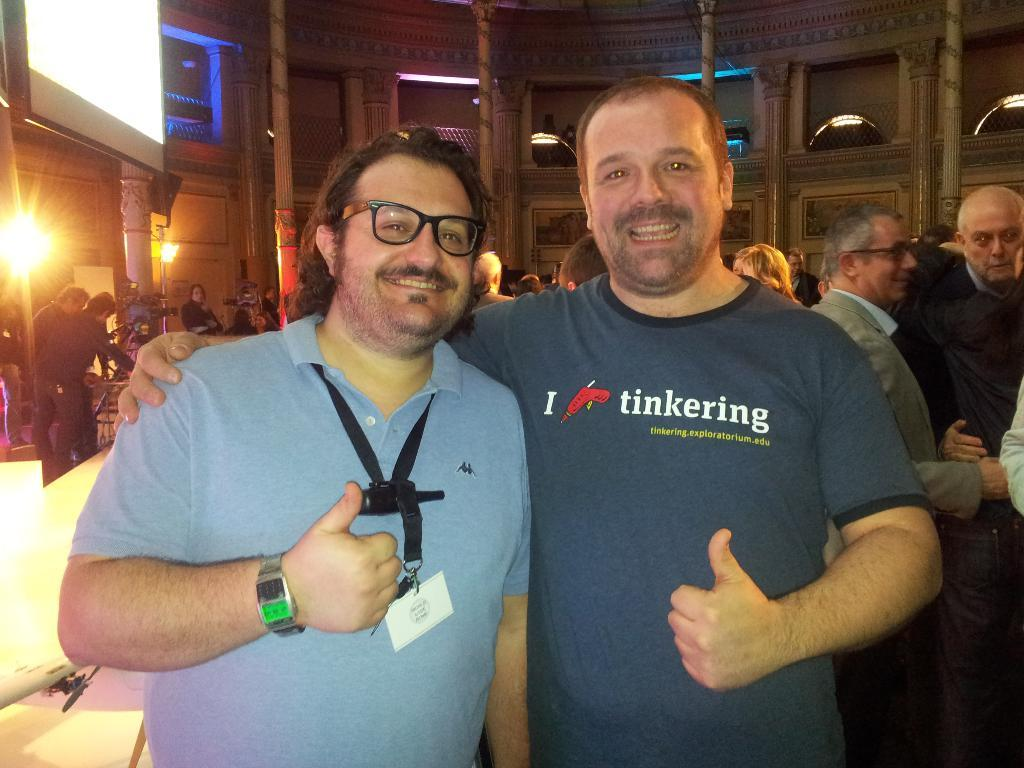How many people are in the image? There are two persons in the image. What is the facial expression of the persons in the image? Both persons have smiling faces. What can be seen in the background of the image? There are buildings, camera stands, and people visible in the background. What features do the buildings have? The buildings have windows and lights. What type of vegetable is being delivered to the stranger in the image? There is no stranger or vegetable delivery present in the image. Where is the mailbox located in the image? There is no mailbox visible in the image. 